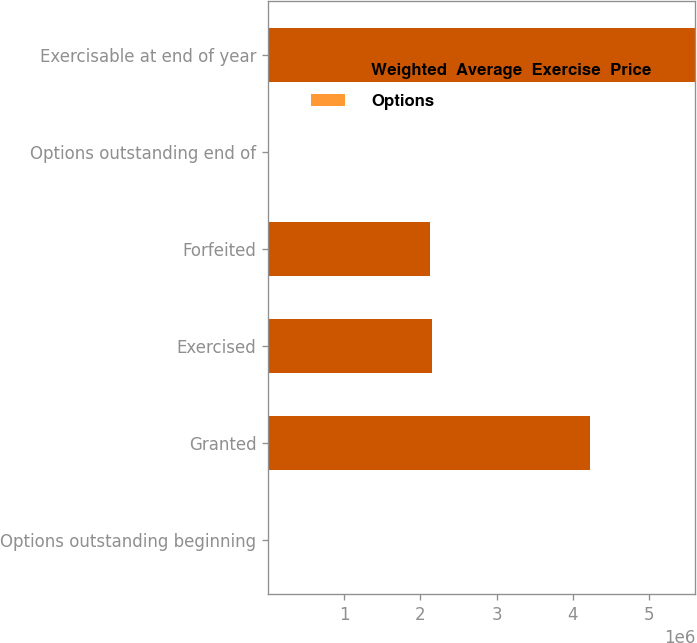Convert chart to OTSL. <chart><loc_0><loc_0><loc_500><loc_500><stacked_bar_chart><ecel><fcel>Options outstanding beginning<fcel>Granted<fcel>Exercised<fcel>Forfeited<fcel>Options outstanding end of<fcel>Exercisable at end of year<nl><fcel>Weighted  Average  Exercise  Price<fcel>28.77<fcel>4.223e+06<fcel>2.1545e+06<fcel>2.1251e+06<fcel>28.77<fcel>5.60742e+06<nl><fcel>Options<fcel>16.59<fcel>31.64<fcel>6.64<fcel>19.7<fcel>21.03<fcel>25.9<nl></chart> 